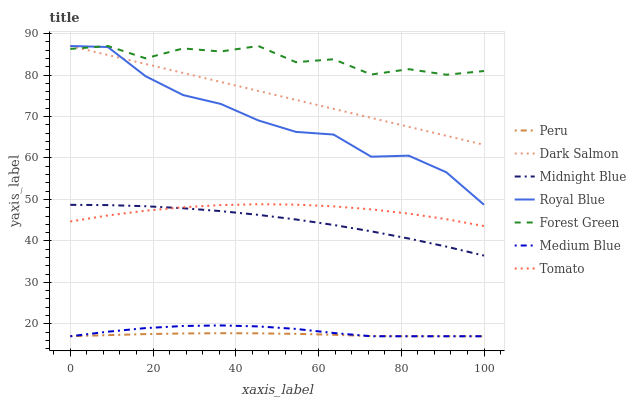Does Peru have the minimum area under the curve?
Answer yes or no. Yes. Does Forest Green have the maximum area under the curve?
Answer yes or no. Yes. Does Midnight Blue have the minimum area under the curve?
Answer yes or no. No. Does Midnight Blue have the maximum area under the curve?
Answer yes or no. No. Is Dark Salmon the smoothest?
Answer yes or no. Yes. Is Forest Green the roughest?
Answer yes or no. Yes. Is Midnight Blue the smoothest?
Answer yes or no. No. Is Midnight Blue the roughest?
Answer yes or no. No. Does Medium Blue have the lowest value?
Answer yes or no. Yes. Does Midnight Blue have the lowest value?
Answer yes or no. No. Does Forest Green have the highest value?
Answer yes or no. Yes. Does Midnight Blue have the highest value?
Answer yes or no. No. Is Tomato less than Forest Green?
Answer yes or no. Yes. Is Midnight Blue greater than Medium Blue?
Answer yes or no. Yes. Does Forest Green intersect Dark Salmon?
Answer yes or no. Yes. Is Forest Green less than Dark Salmon?
Answer yes or no. No. Is Forest Green greater than Dark Salmon?
Answer yes or no. No. Does Tomato intersect Forest Green?
Answer yes or no. No. 